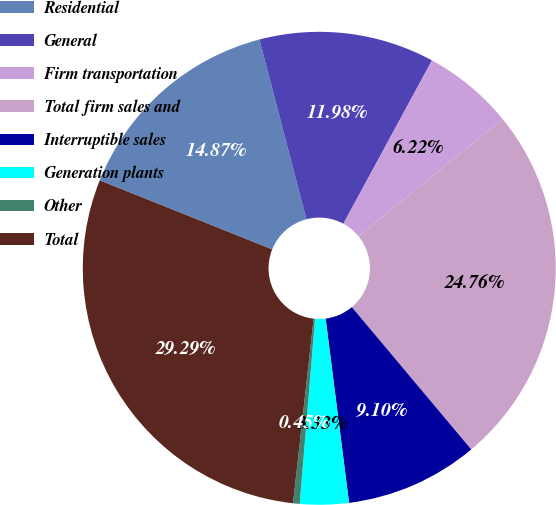Convert chart to OTSL. <chart><loc_0><loc_0><loc_500><loc_500><pie_chart><fcel>Residential<fcel>General<fcel>Firm transportation<fcel>Total firm sales and<fcel>Interruptible sales<fcel>Generation plants<fcel>Other<fcel>Total<nl><fcel>14.87%<fcel>11.98%<fcel>6.22%<fcel>24.76%<fcel>9.1%<fcel>3.33%<fcel>0.45%<fcel>29.29%<nl></chart> 